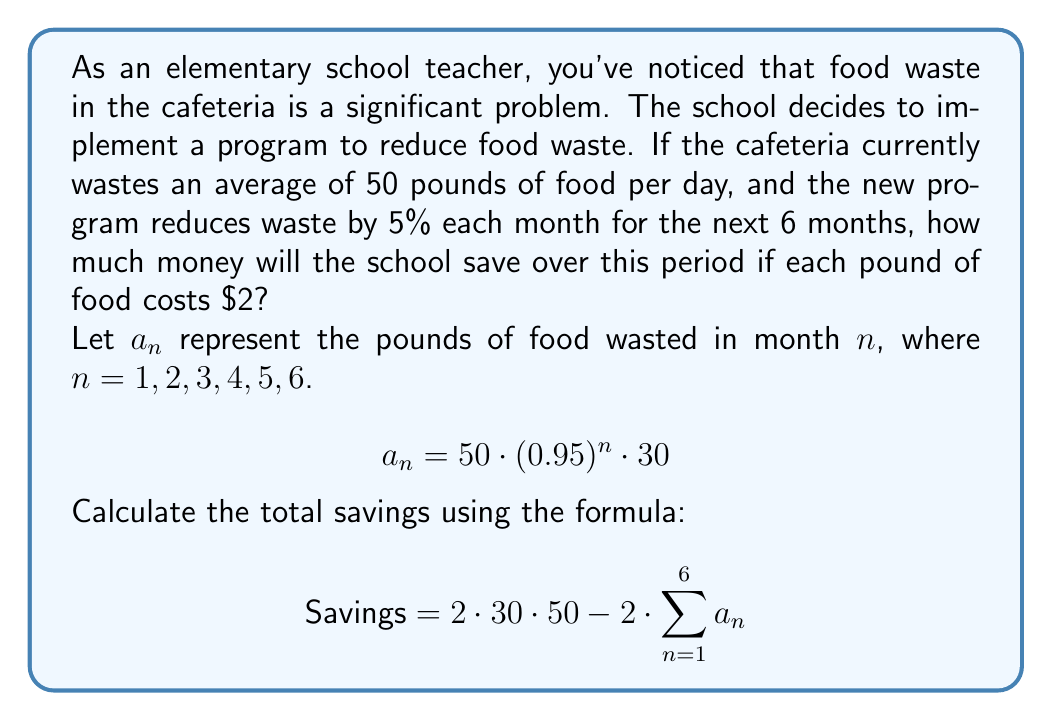Solve this math problem. Let's break this down step-by-step:

1) First, we need to calculate the amount of food wasted each month:

   Month 1: $a_1 = 50 \cdot (0.95)^1 \cdot 30 = 1425$ pounds
   Month 2: $a_2 = 50 \cdot (0.95)^2 \cdot 30 = 1353.75$ pounds
   Month 3: $a_3 = 50 \cdot (0.95)^3 \cdot 30 = 1286.06$ pounds
   Month 4: $a_4 = 50 \cdot (0.95)^4 \cdot 30 = 1221.76$ pounds
   Month 5: $a_5 = 50 \cdot (0.95)^5 \cdot 30 = 1160.67$ pounds
   Month 6: $a_6 = 50 \cdot (0.95)^6 \cdot 30 = 1102.64$ pounds

2) Now, we sum up the total waste over 6 months:

   $\sum_{n=1}^6 a_n = 1425 + 1353.75 + 1286.06 + 1221.76 + 1160.67 + 1102.64 = 7549.88$ pounds

3) If there was no reduction in waste, the total waste over 6 months would be:
   
   $50 \cdot 30 \cdot 6 = 9000$ pounds

4) The difference in waste is:
   
   $9000 - 7549.88 = 1450.12$ pounds

5) Each pound costs $2, so the total savings is:

   $1450.12 \cdot 2 = $2900.24$

Therefore, the school will save $2900.24 over the 6-month period.
Answer: $2900.24 